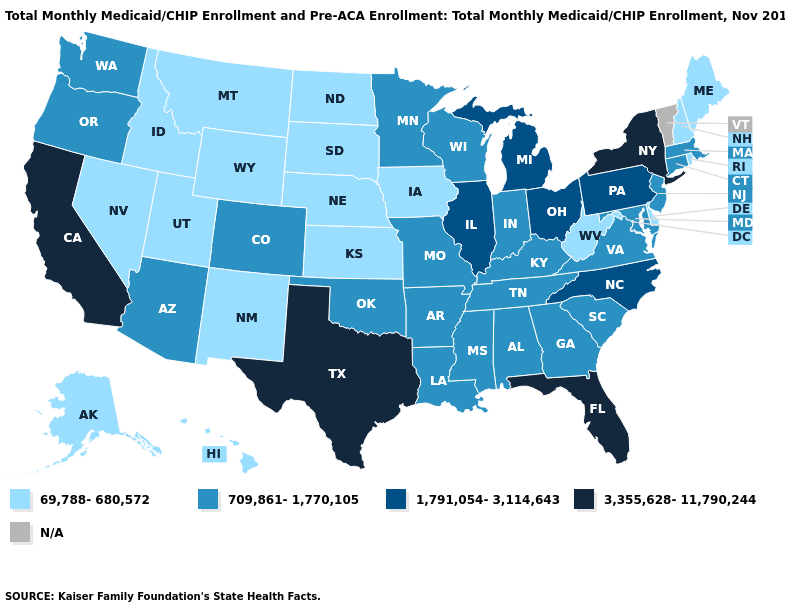Among the states that border Utah , does Colorado have the highest value?
Quick response, please. Yes. Name the states that have a value in the range 69,788-680,572?
Answer briefly. Alaska, Delaware, Hawaii, Idaho, Iowa, Kansas, Maine, Montana, Nebraska, Nevada, New Hampshire, New Mexico, North Dakota, Rhode Island, South Dakota, Utah, West Virginia, Wyoming. Which states have the lowest value in the USA?
Answer briefly. Alaska, Delaware, Hawaii, Idaho, Iowa, Kansas, Maine, Montana, Nebraska, Nevada, New Hampshire, New Mexico, North Dakota, Rhode Island, South Dakota, Utah, West Virginia, Wyoming. What is the value of West Virginia?
Keep it brief. 69,788-680,572. Is the legend a continuous bar?
Short answer required. No. Name the states that have a value in the range 3,355,628-11,790,244?
Concise answer only. California, Florida, New York, Texas. Does Nevada have the lowest value in the West?
Give a very brief answer. Yes. Among the states that border Kentucky , does West Virginia have the lowest value?
Short answer required. Yes. Which states have the highest value in the USA?
Concise answer only. California, Florida, New York, Texas. Which states hav the highest value in the Northeast?
Keep it brief. New York. Among the states that border Wyoming , does Utah have the highest value?
Answer briefly. No. What is the highest value in the USA?
Answer briefly. 3,355,628-11,790,244. Which states have the lowest value in the USA?
Short answer required. Alaska, Delaware, Hawaii, Idaho, Iowa, Kansas, Maine, Montana, Nebraska, Nevada, New Hampshire, New Mexico, North Dakota, Rhode Island, South Dakota, Utah, West Virginia, Wyoming. 